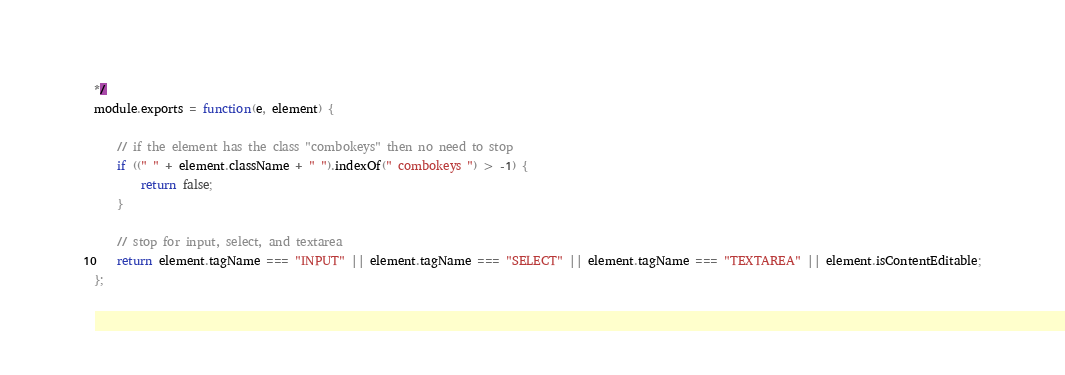Convert code to text. <code><loc_0><loc_0><loc_500><loc_500><_JavaScript_>*/
module.exports = function(e, element) {

    // if the element has the class "combokeys" then no need to stop
    if ((" " + element.className + " ").indexOf(" combokeys ") > -1) {
        return false;
    }

    // stop for input, select, and textarea
    return element.tagName === "INPUT" || element.tagName === "SELECT" || element.tagName === "TEXTAREA" || element.isContentEditable;
};
</code> 